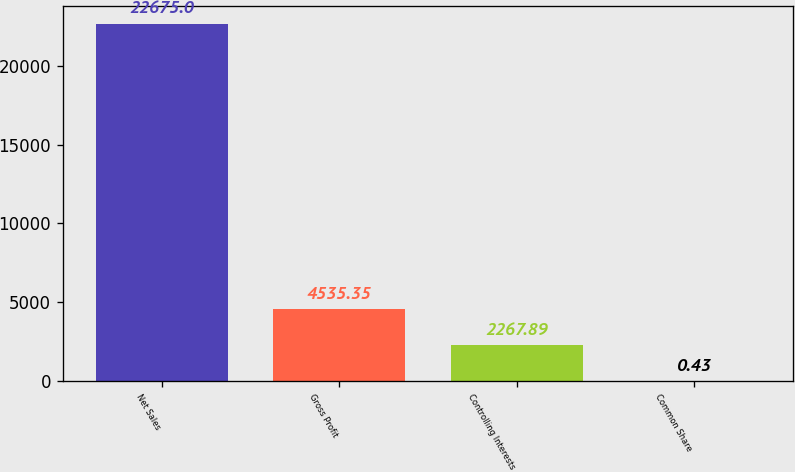<chart> <loc_0><loc_0><loc_500><loc_500><bar_chart><fcel>Net Sales<fcel>Gross Profit<fcel>Controlling Interests<fcel>Common Share<nl><fcel>22675<fcel>4535.35<fcel>2267.89<fcel>0.43<nl></chart> 